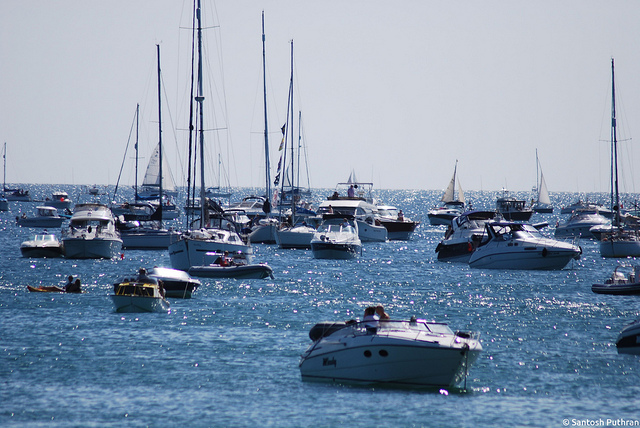Please transcribe the text information in this image. SANTOSH Puthran 